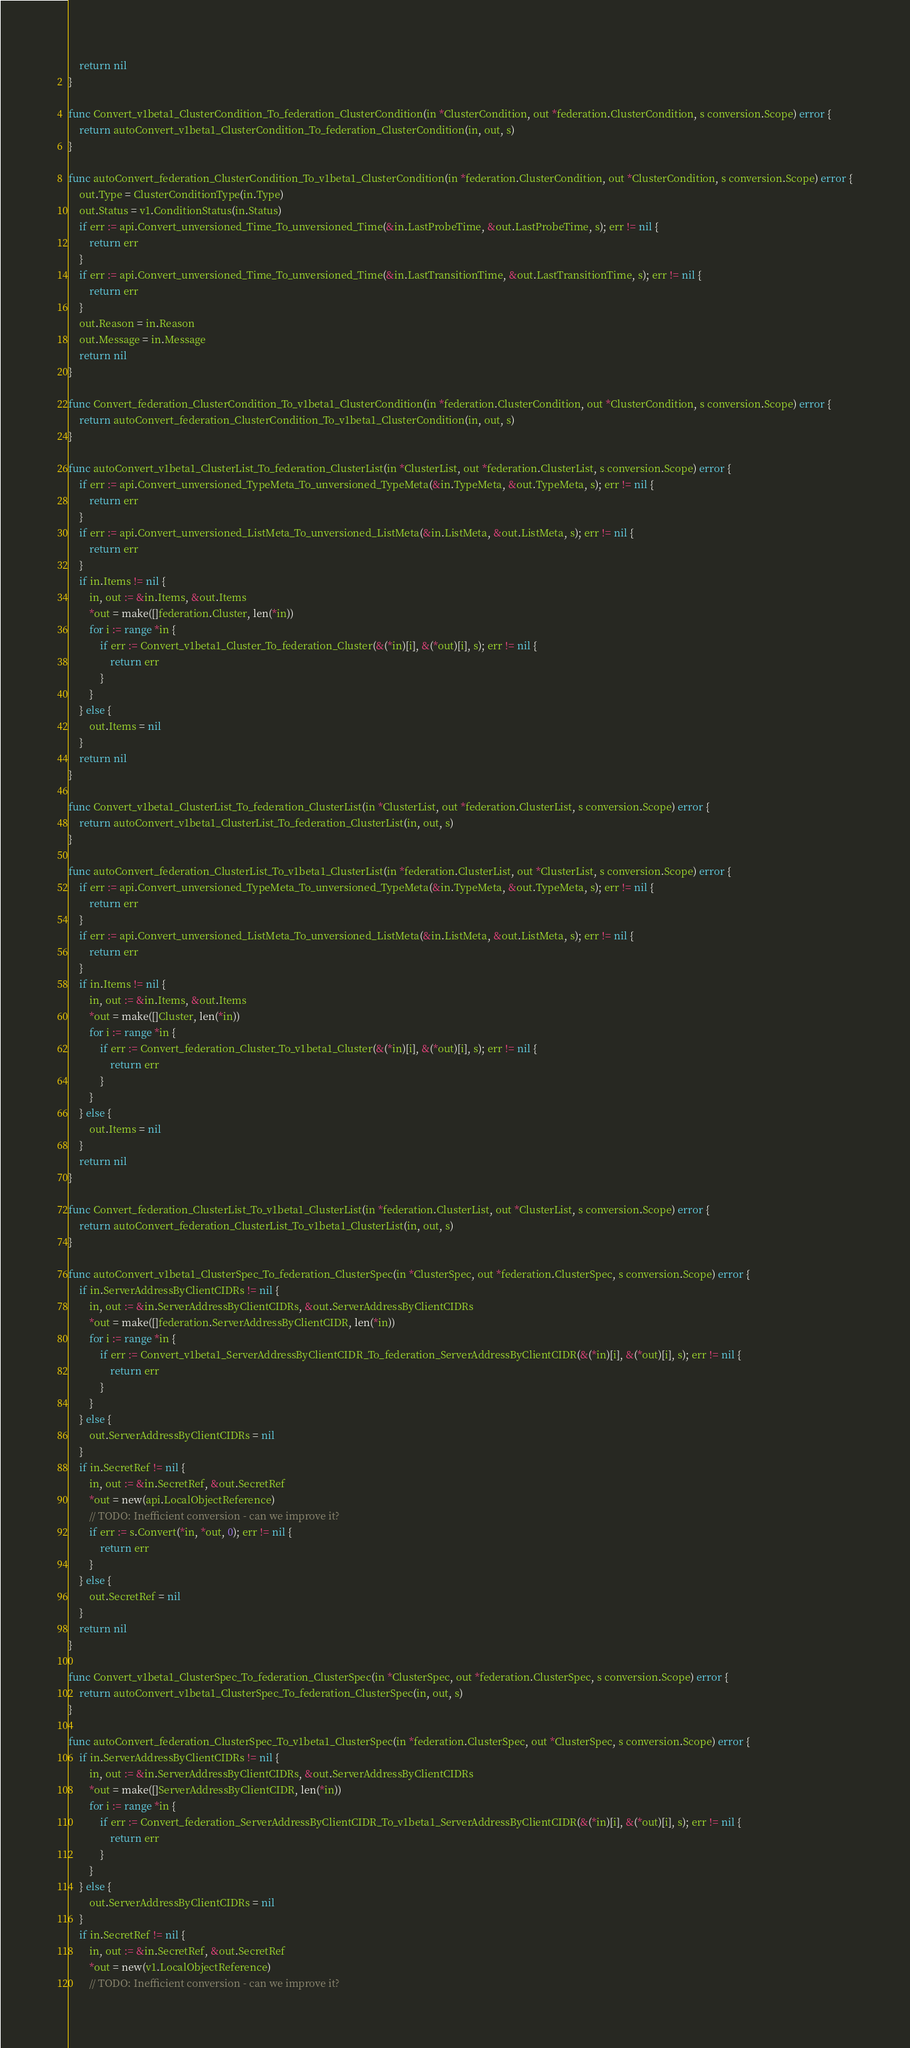Convert code to text. <code><loc_0><loc_0><loc_500><loc_500><_Go_>	return nil
}

func Convert_v1beta1_ClusterCondition_To_federation_ClusterCondition(in *ClusterCondition, out *federation.ClusterCondition, s conversion.Scope) error {
	return autoConvert_v1beta1_ClusterCondition_To_federation_ClusterCondition(in, out, s)
}

func autoConvert_federation_ClusterCondition_To_v1beta1_ClusterCondition(in *federation.ClusterCondition, out *ClusterCondition, s conversion.Scope) error {
	out.Type = ClusterConditionType(in.Type)
	out.Status = v1.ConditionStatus(in.Status)
	if err := api.Convert_unversioned_Time_To_unversioned_Time(&in.LastProbeTime, &out.LastProbeTime, s); err != nil {
		return err
	}
	if err := api.Convert_unversioned_Time_To_unversioned_Time(&in.LastTransitionTime, &out.LastTransitionTime, s); err != nil {
		return err
	}
	out.Reason = in.Reason
	out.Message = in.Message
	return nil
}

func Convert_federation_ClusterCondition_To_v1beta1_ClusterCondition(in *federation.ClusterCondition, out *ClusterCondition, s conversion.Scope) error {
	return autoConvert_federation_ClusterCondition_To_v1beta1_ClusterCondition(in, out, s)
}

func autoConvert_v1beta1_ClusterList_To_federation_ClusterList(in *ClusterList, out *federation.ClusterList, s conversion.Scope) error {
	if err := api.Convert_unversioned_TypeMeta_To_unversioned_TypeMeta(&in.TypeMeta, &out.TypeMeta, s); err != nil {
		return err
	}
	if err := api.Convert_unversioned_ListMeta_To_unversioned_ListMeta(&in.ListMeta, &out.ListMeta, s); err != nil {
		return err
	}
	if in.Items != nil {
		in, out := &in.Items, &out.Items
		*out = make([]federation.Cluster, len(*in))
		for i := range *in {
			if err := Convert_v1beta1_Cluster_To_federation_Cluster(&(*in)[i], &(*out)[i], s); err != nil {
				return err
			}
		}
	} else {
		out.Items = nil
	}
	return nil
}

func Convert_v1beta1_ClusterList_To_federation_ClusterList(in *ClusterList, out *federation.ClusterList, s conversion.Scope) error {
	return autoConvert_v1beta1_ClusterList_To_federation_ClusterList(in, out, s)
}

func autoConvert_federation_ClusterList_To_v1beta1_ClusterList(in *federation.ClusterList, out *ClusterList, s conversion.Scope) error {
	if err := api.Convert_unversioned_TypeMeta_To_unversioned_TypeMeta(&in.TypeMeta, &out.TypeMeta, s); err != nil {
		return err
	}
	if err := api.Convert_unversioned_ListMeta_To_unversioned_ListMeta(&in.ListMeta, &out.ListMeta, s); err != nil {
		return err
	}
	if in.Items != nil {
		in, out := &in.Items, &out.Items
		*out = make([]Cluster, len(*in))
		for i := range *in {
			if err := Convert_federation_Cluster_To_v1beta1_Cluster(&(*in)[i], &(*out)[i], s); err != nil {
				return err
			}
		}
	} else {
		out.Items = nil
	}
	return nil
}

func Convert_federation_ClusterList_To_v1beta1_ClusterList(in *federation.ClusterList, out *ClusterList, s conversion.Scope) error {
	return autoConvert_federation_ClusterList_To_v1beta1_ClusterList(in, out, s)
}

func autoConvert_v1beta1_ClusterSpec_To_federation_ClusterSpec(in *ClusterSpec, out *federation.ClusterSpec, s conversion.Scope) error {
	if in.ServerAddressByClientCIDRs != nil {
		in, out := &in.ServerAddressByClientCIDRs, &out.ServerAddressByClientCIDRs
		*out = make([]federation.ServerAddressByClientCIDR, len(*in))
		for i := range *in {
			if err := Convert_v1beta1_ServerAddressByClientCIDR_To_federation_ServerAddressByClientCIDR(&(*in)[i], &(*out)[i], s); err != nil {
				return err
			}
		}
	} else {
		out.ServerAddressByClientCIDRs = nil
	}
	if in.SecretRef != nil {
		in, out := &in.SecretRef, &out.SecretRef
		*out = new(api.LocalObjectReference)
		// TODO: Inefficient conversion - can we improve it?
		if err := s.Convert(*in, *out, 0); err != nil {
			return err
		}
	} else {
		out.SecretRef = nil
	}
	return nil
}

func Convert_v1beta1_ClusterSpec_To_federation_ClusterSpec(in *ClusterSpec, out *federation.ClusterSpec, s conversion.Scope) error {
	return autoConvert_v1beta1_ClusterSpec_To_federation_ClusterSpec(in, out, s)
}

func autoConvert_federation_ClusterSpec_To_v1beta1_ClusterSpec(in *federation.ClusterSpec, out *ClusterSpec, s conversion.Scope) error {
	if in.ServerAddressByClientCIDRs != nil {
		in, out := &in.ServerAddressByClientCIDRs, &out.ServerAddressByClientCIDRs
		*out = make([]ServerAddressByClientCIDR, len(*in))
		for i := range *in {
			if err := Convert_federation_ServerAddressByClientCIDR_To_v1beta1_ServerAddressByClientCIDR(&(*in)[i], &(*out)[i], s); err != nil {
				return err
			}
		}
	} else {
		out.ServerAddressByClientCIDRs = nil
	}
	if in.SecretRef != nil {
		in, out := &in.SecretRef, &out.SecretRef
		*out = new(v1.LocalObjectReference)
		// TODO: Inefficient conversion - can we improve it?</code> 